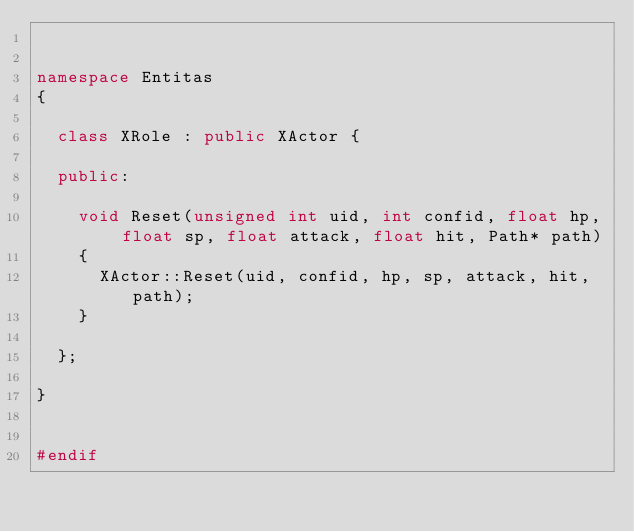<code> <loc_0><loc_0><loc_500><loc_500><_C++_>

namespace Entitas
{

	class XRole : public XActor {

	public:

		void Reset(unsigned int uid, int confid, float hp, float sp, float attack, float hit, Path* path)
		{
			XActor::Reset(uid, confid, hp, sp, attack, hit, path);
		}

	};

}


#endif
</code> 